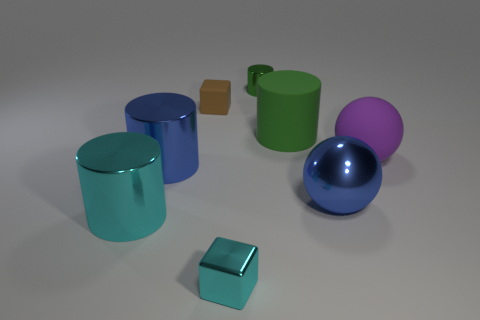Subtract all large blue cylinders. How many cylinders are left? 3 Add 1 large green things. How many objects exist? 9 Subtract all green cylinders. How many cylinders are left? 2 Subtract 0 gray balls. How many objects are left? 8 Subtract 3 cylinders. How many cylinders are left? 1 Subtract all red cylinders. Subtract all purple blocks. How many cylinders are left? 4 Subtract all yellow cylinders. How many brown blocks are left? 1 Subtract all cyan shiny cylinders. Subtract all big matte objects. How many objects are left? 5 Add 1 big purple objects. How many big purple objects are left? 2 Add 8 blue balls. How many blue balls exist? 9 